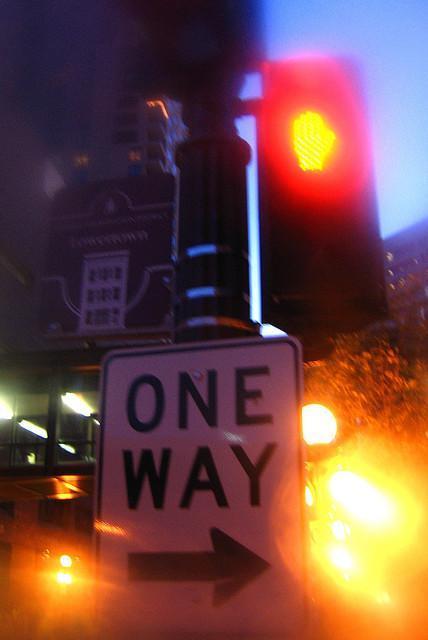How many traffic lights are visible?
Give a very brief answer. 1. 